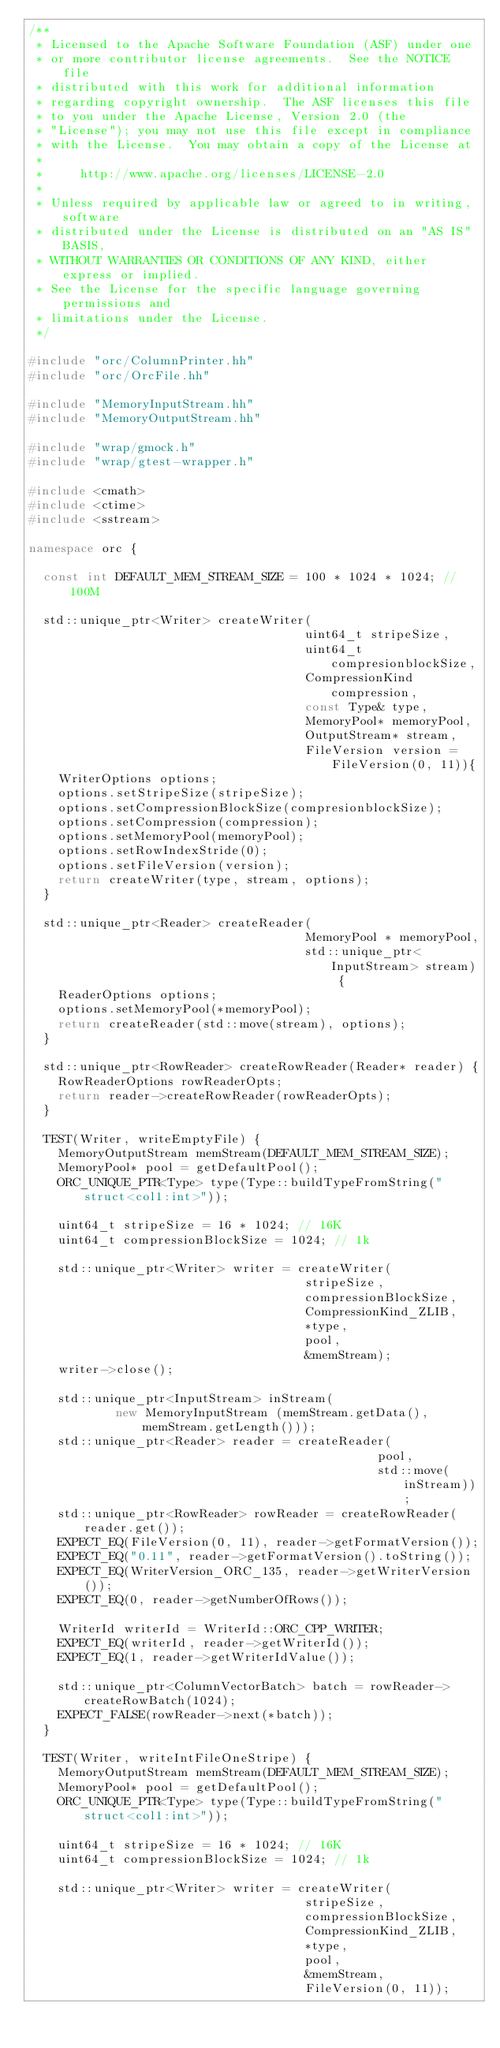Convert code to text. <code><loc_0><loc_0><loc_500><loc_500><_C++_>/**
 * Licensed to the Apache Software Foundation (ASF) under one
 * or more contributor license agreements.  See the NOTICE file
 * distributed with this work for additional information
 * regarding copyright ownership.  The ASF licenses this file
 * to you under the Apache License, Version 2.0 (the
 * "License"); you may not use this file except in compliance
 * with the License.  You may obtain a copy of the License at
 *
 *     http://www.apache.org/licenses/LICENSE-2.0
 *
 * Unless required by applicable law or agreed to in writing, software
 * distributed under the License is distributed on an "AS IS" BASIS,
 * WITHOUT WARRANTIES OR CONDITIONS OF ANY KIND, either express or implied.
 * See the License for the specific language governing permissions and
 * limitations under the License.
 */

#include "orc/ColumnPrinter.hh"
#include "orc/OrcFile.hh"

#include "MemoryInputStream.hh"
#include "MemoryOutputStream.hh"

#include "wrap/gmock.h"
#include "wrap/gtest-wrapper.h"

#include <cmath>
#include <ctime>
#include <sstream>

namespace orc {

  const int DEFAULT_MEM_STREAM_SIZE = 100 * 1024 * 1024; // 100M

  std::unique_ptr<Writer> createWriter(
                                      uint64_t stripeSize,
                                      uint64_t compresionblockSize,
                                      CompressionKind compression,
                                      const Type& type,
                                      MemoryPool* memoryPool,
                                      OutputStream* stream,
                                      FileVersion version = FileVersion(0, 11)){
    WriterOptions options;
    options.setStripeSize(stripeSize);
    options.setCompressionBlockSize(compresionblockSize);
    options.setCompression(compression);
    options.setMemoryPool(memoryPool);
    options.setRowIndexStride(0);
    options.setFileVersion(version);
    return createWriter(type, stream, options);
  }

  std::unique_ptr<Reader> createReader(
                                      MemoryPool * memoryPool,
                                      std::unique_ptr<InputStream> stream) {
    ReaderOptions options;
    options.setMemoryPool(*memoryPool);
    return createReader(std::move(stream), options);
  }

  std::unique_ptr<RowReader> createRowReader(Reader* reader) {
    RowReaderOptions rowReaderOpts;
    return reader->createRowReader(rowReaderOpts);
  }

  TEST(Writer, writeEmptyFile) {
    MemoryOutputStream memStream(DEFAULT_MEM_STREAM_SIZE);
    MemoryPool* pool = getDefaultPool();
    ORC_UNIQUE_PTR<Type> type(Type::buildTypeFromString("struct<col1:int>"));

    uint64_t stripeSize = 16 * 1024; // 16K
    uint64_t compressionBlockSize = 1024; // 1k

    std::unique_ptr<Writer> writer = createWriter(
                                      stripeSize,
                                      compressionBlockSize,
                                      CompressionKind_ZLIB,
                                      *type,
                                      pool,
                                      &memStream);
    writer->close();

    std::unique_ptr<InputStream> inStream(
            new MemoryInputStream (memStream.getData(), memStream.getLength()));
    std::unique_ptr<Reader> reader = createReader(
                                                pool,
                                                std::move(inStream));
    std::unique_ptr<RowReader> rowReader = createRowReader(reader.get());
    EXPECT_EQ(FileVersion(0, 11), reader->getFormatVersion());
    EXPECT_EQ("0.11", reader->getFormatVersion().toString());
    EXPECT_EQ(WriterVersion_ORC_135, reader->getWriterVersion());
    EXPECT_EQ(0, reader->getNumberOfRows());

    WriterId writerId = WriterId::ORC_CPP_WRITER;
    EXPECT_EQ(writerId, reader->getWriterId());
    EXPECT_EQ(1, reader->getWriterIdValue());

    std::unique_ptr<ColumnVectorBatch> batch = rowReader->createRowBatch(1024);
    EXPECT_FALSE(rowReader->next(*batch));
  }

  TEST(Writer, writeIntFileOneStripe) {
    MemoryOutputStream memStream(DEFAULT_MEM_STREAM_SIZE);
    MemoryPool* pool = getDefaultPool();
    ORC_UNIQUE_PTR<Type> type(Type::buildTypeFromString("struct<col1:int>"));

    uint64_t stripeSize = 16 * 1024; // 16K
    uint64_t compressionBlockSize = 1024; // 1k

    std::unique_ptr<Writer> writer = createWriter(
                                      stripeSize,
                                      compressionBlockSize,
                                      CompressionKind_ZLIB,
                                      *type,
                                      pool,
                                      &memStream,
                                      FileVersion(0, 11));</code> 